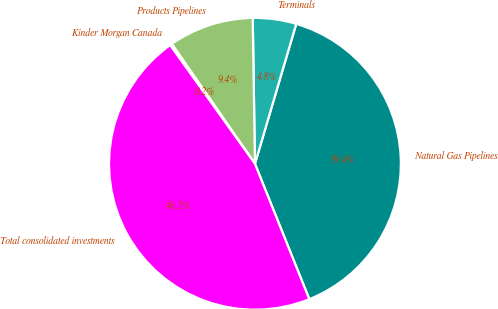Convert chart to OTSL. <chart><loc_0><loc_0><loc_500><loc_500><pie_chart><fcel>Natural Gas Pipelines<fcel>Terminals<fcel>Products Pipelines<fcel>Kinder Morgan Canada<fcel>Total consolidated investments<nl><fcel>39.36%<fcel>4.81%<fcel>9.41%<fcel>0.22%<fcel>46.2%<nl></chart> 